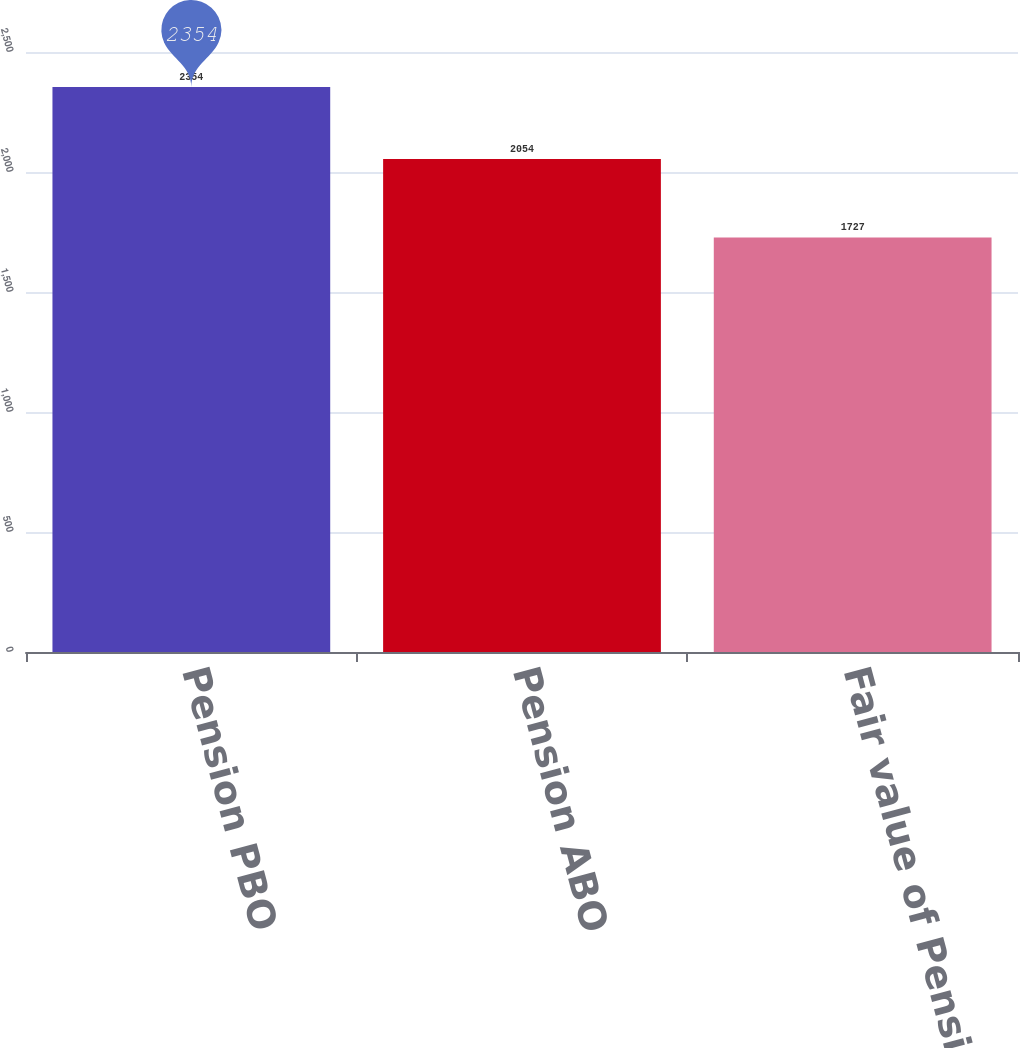<chart> <loc_0><loc_0><loc_500><loc_500><bar_chart><fcel>Pension PBO<fcel>Pension ABO<fcel>Fair value of Pension Plan<nl><fcel>2354<fcel>2054<fcel>1727<nl></chart> 